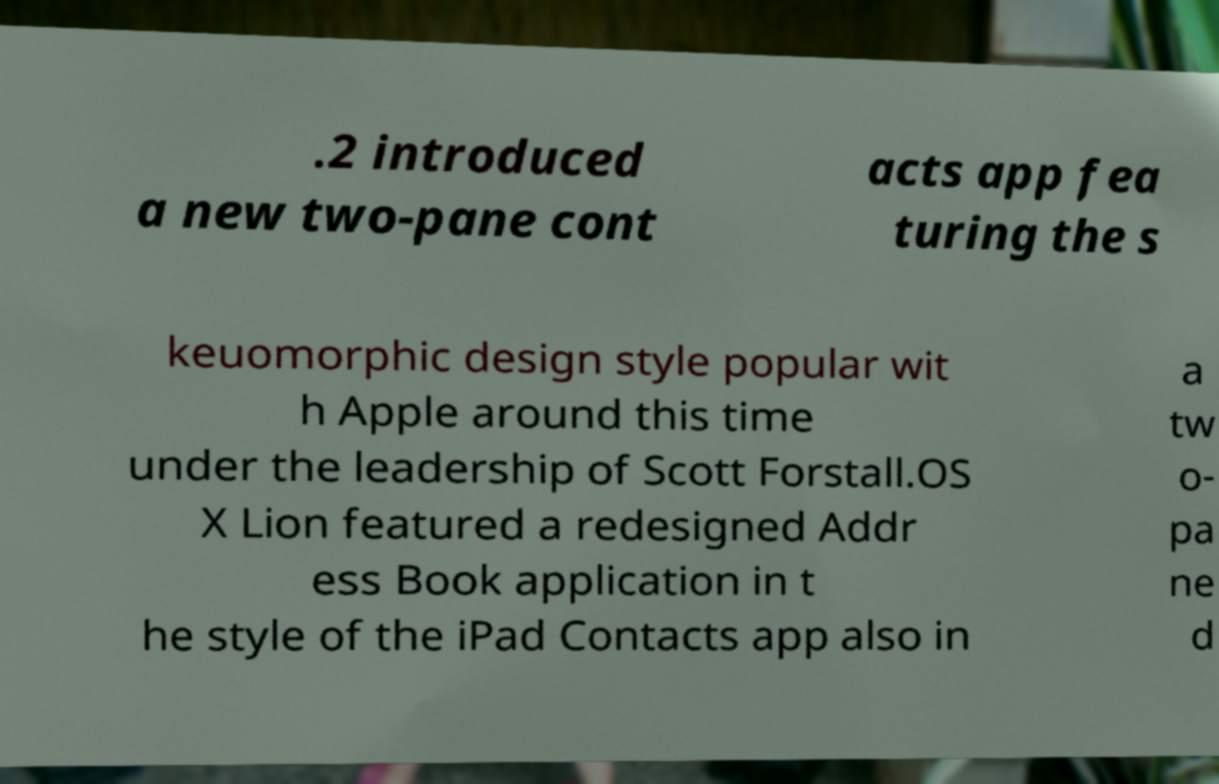I need the written content from this picture converted into text. Can you do that? .2 introduced a new two-pane cont acts app fea turing the s keuomorphic design style popular wit h Apple around this time under the leadership of Scott Forstall.OS X Lion featured a redesigned Addr ess Book application in t he style of the iPad Contacts app also in a tw o- pa ne d 